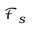<formula> <loc_0><loc_0><loc_500><loc_500>{ \mathcal { F } } _ { s }</formula> 